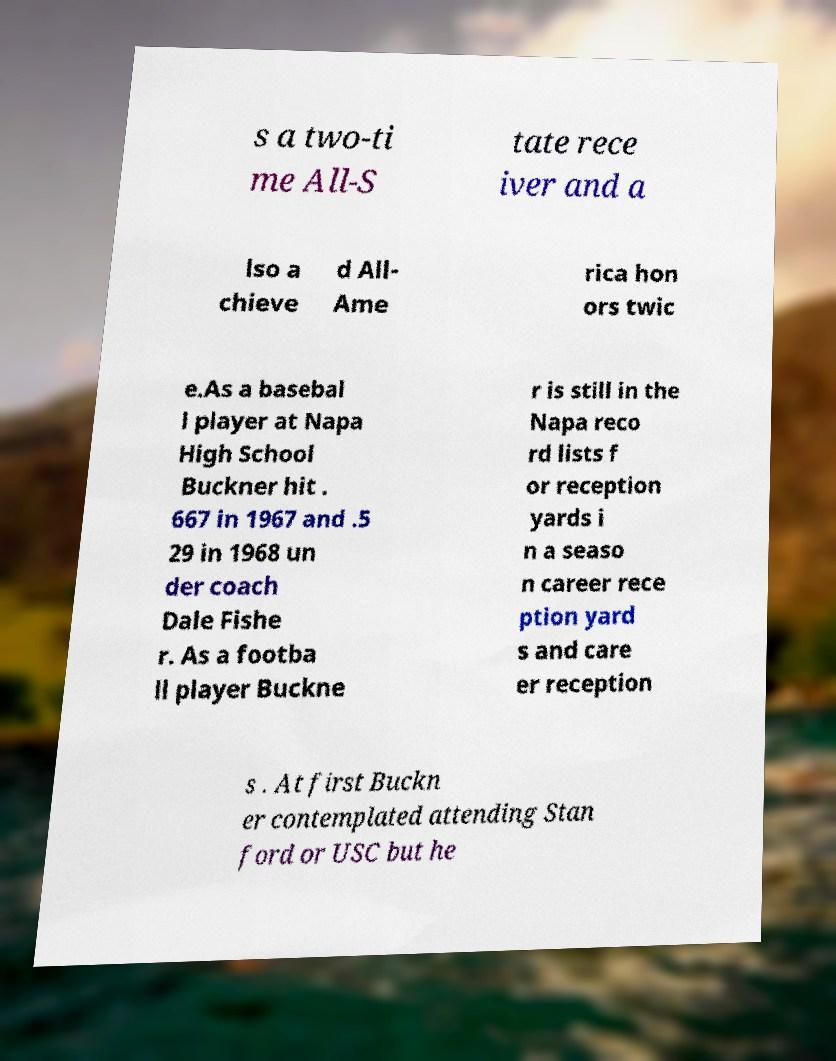For documentation purposes, I need the text within this image transcribed. Could you provide that? s a two-ti me All-S tate rece iver and a lso a chieve d All- Ame rica hon ors twic e.As a basebal l player at Napa High School Buckner hit . 667 in 1967 and .5 29 in 1968 un der coach Dale Fishe r. As a footba ll player Buckne r is still in the Napa reco rd lists f or reception yards i n a seaso n career rece ption yard s and care er reception s . At first Buckn er contemplated attending Stan ford or USC but he 